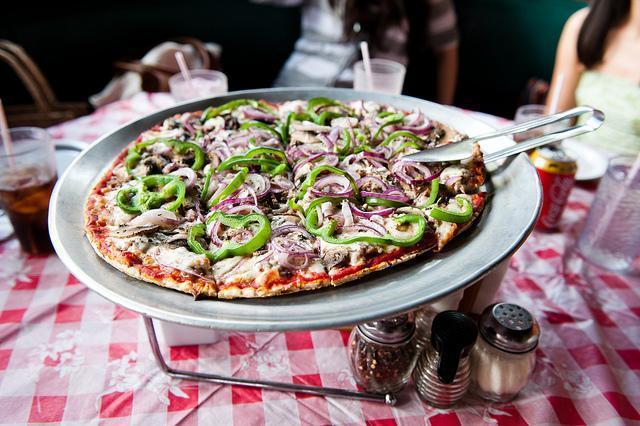How many cups are in the photo?
Give a very brief answer. 2. How many people are there?
Give a very brief answer. 2. How many bikes are there?
Give a very brief answer. 0. 